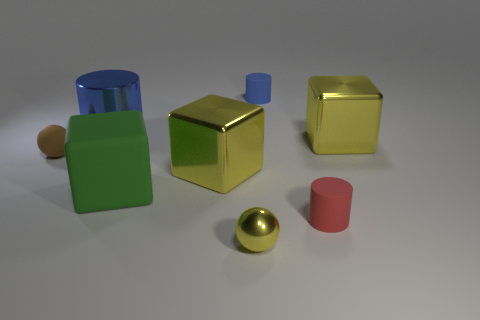Subtract all large green cubes. How many cubes are left? 2 Add 1 tiny blue rubber objects. How many objects exist? 9 Subtract all blocks. How many objects are left? 5 Subtract all blue cylinders. How many cylinders are left? 1 Subtract 3 blocks. How many blocks are left? 0 Subtract all brown cubes. Subtract all red cylinders. How many cubes are left? 3 Subtract all brown cubes. How many gray spheres are left? 0 Subtract all brown balls. Subtract all tiny blue matte objects. How many objects are left? 6 Add 3 cylinders. How many cylinders are left? 6 Add 6 big blue cylinders. How many big blue cylinders exist? 7 